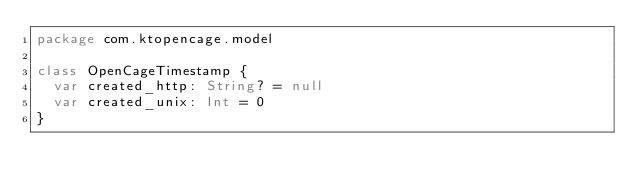Convert code to text. <code><loc_0><loc_0><loc_500><loc_500><_Kotlin_>package com.ktopencage.model

class OpenCageTimestamp {
  var created_http: String? = null
  var created_unix: Int = 0
}
</code> 